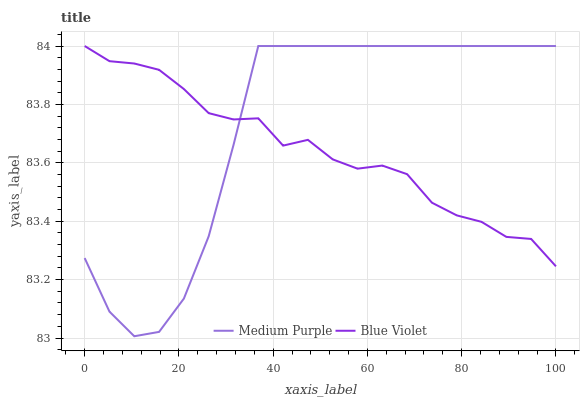Does Blue Violet have the minimum area under the curve?
Answer yes or no. Yes. Does Medium Purple have the maximum area under the curve?
Answer yes or no. Yes. Does Blue Violet have the maximum area under the curve?
Answer yes or no. No. Is Medium Purple the smoothest?
Answer yes or no. Yes. Is Blue Violet the roughest?
Answer yes or no. Yes. Is Blue Violet the smoothest?
Answer yes or no. No. Does Medium Purple have the lowest value?
Answer yes or no. Yes. Does Blue Violet have the lowest value?
Answer yes or no. No. Does Blue Violet have the highest value?
Answer yes or no. Yes. Does Medium Purple intersect Blue Violet?
Answer yes or no. Yes. Is Medium Purple less than Blue Violet?
Answer yes or no. No. Is Medium Purple greater than Blue Violet?
Answer yes or no. No. 